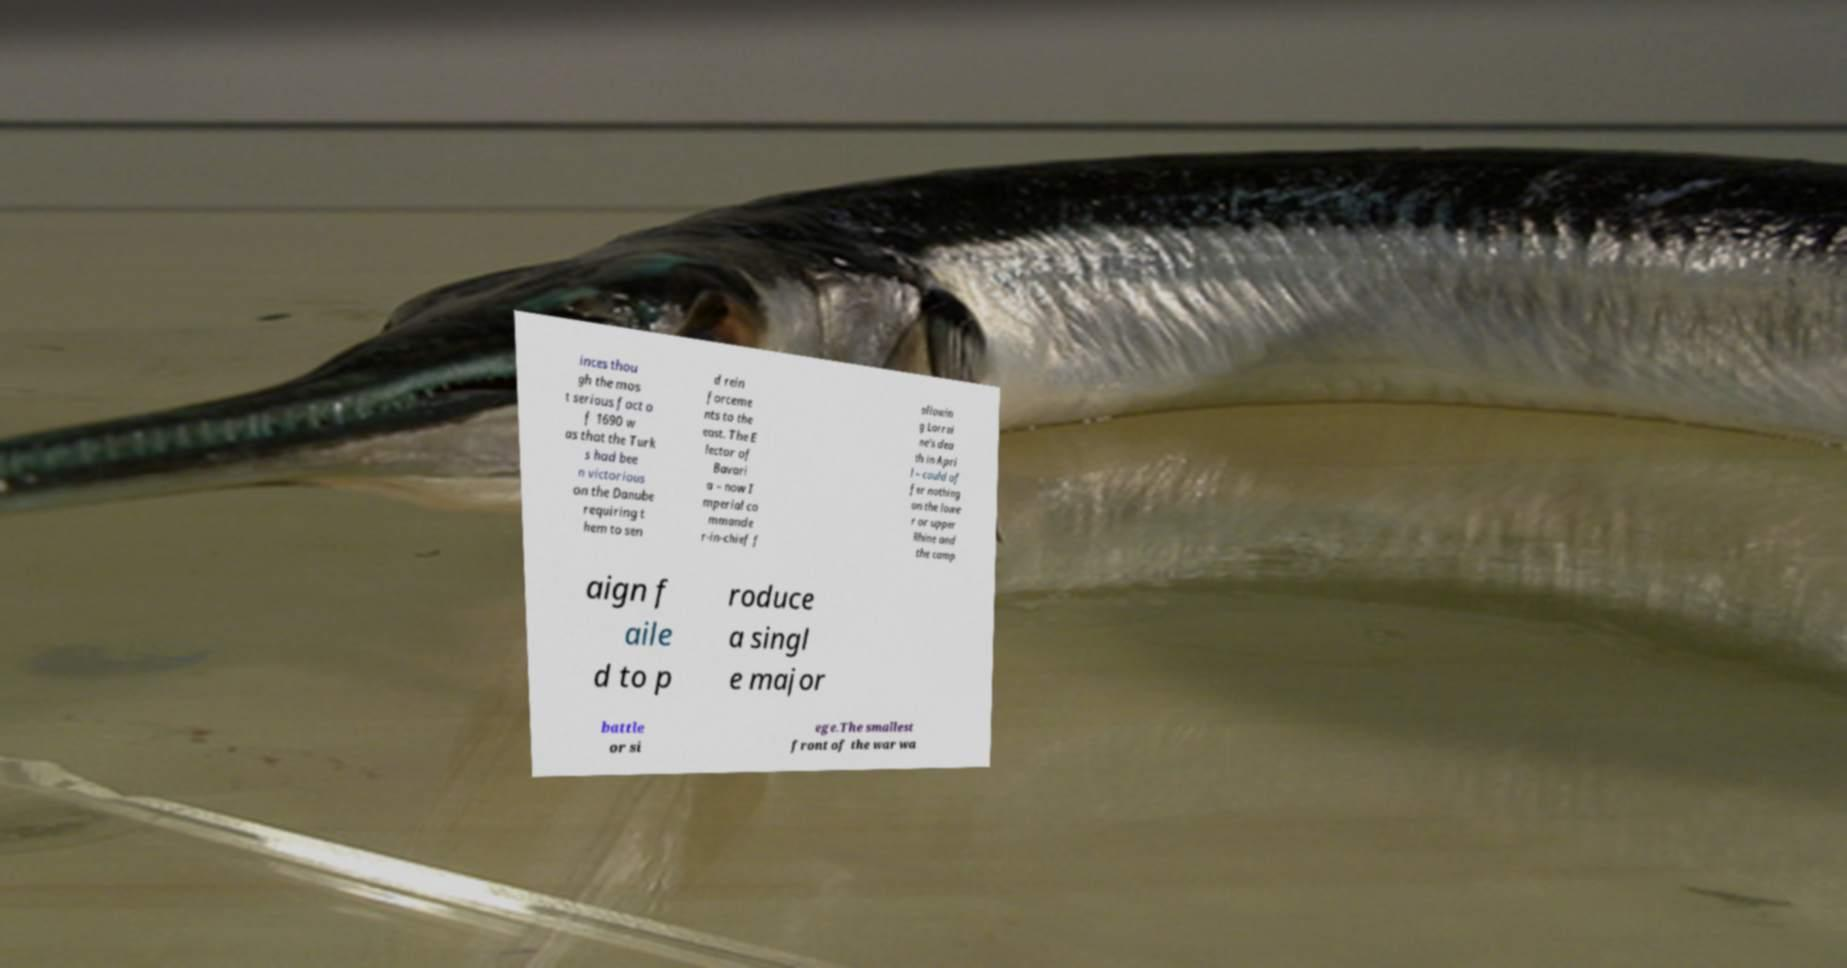There's text embedded in this image that I need extracted. Can you transcribe it verbatim? inces thou gh the mos t serious fact o f 1690 w as that the Turk s had bee n victorious on the Danube requiring t hem to sen d rein forceme nts to the east. The E lector of Bavari a – now I mperial co mmande r-in-chief f ollowin g Lorrai ne's dea th in Apri l – could of fer nothing on the lowe r or upper Rhine and the camp aign f aile d to p roduce a singl e major battle or si ege.The smallest front of the war wa 